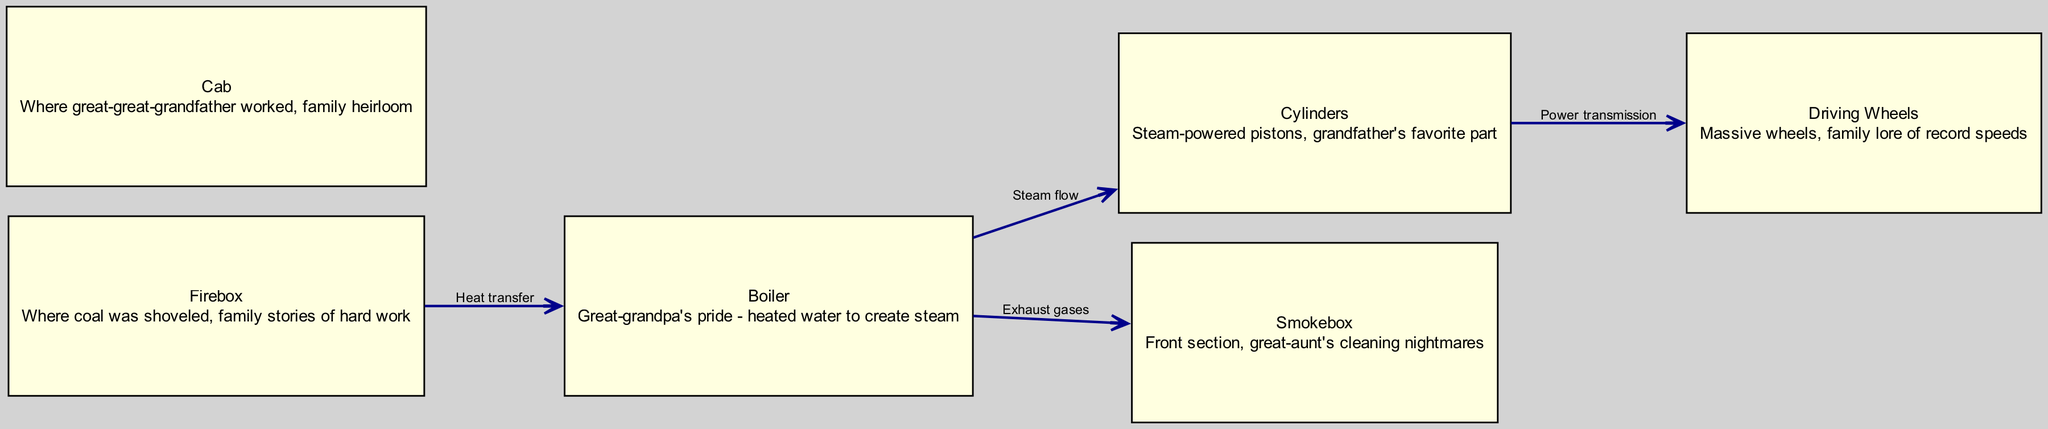What is the primary function of the boiler? The boiler's main function is to heat water to create steam, as described in the node labeled "Boiler."
Answer: Heats water to create steam How many nodes are present in the diagram? By counting the nodes listed (boiler, firebox, cylinders, wheels, smokebox, cab), we find a total of six nodes in the diagram.
Answer: Six What connects the firebox and the boiler? The diagram specifies a relationship labeled "Heat transfer," indicating the connection between the firebox and the boiler.
Answer: Heat transfer What is the relationship between the cylinders and the wheels? The arrows indicate that the cylinders are connected to the wheels through the relationship labeled "Power transmission." This implies that the cylinders provide power to the wheels.
Answer: Power transmission Which component handles the exhaust gases in the locomotive? According to the diagram, the node labeled "Smokebox" is directly connected to the boiler, signifying that it handles exhaust gases.
Answer: Smokebox Which component did great-great-grandfather work in? The diary mentions the "Cab" as where great-great-grandfather worked, which is explicitly stated in the node descriptions.
Answer: Cab What kind of stories are associated with the firebox? Family stories tell of hard work related to the firebox, as it is where coal was shoveled, which is detailed in the description of the firebox node.
Answer: Hard work How does steam flow from the boiler to the cylinders? The arrows connecting the boiler and the cylinders are labeled "Steam flow," indicating the pathway for steam to travel from the boiler to the cylinders.
Answer: Steam flow What are the massive wheels known for in family lore? Family lore recounts that the massive wheels were associated with record speeds, as conveyed in the wheel node's description.
Answer: Record speeds 